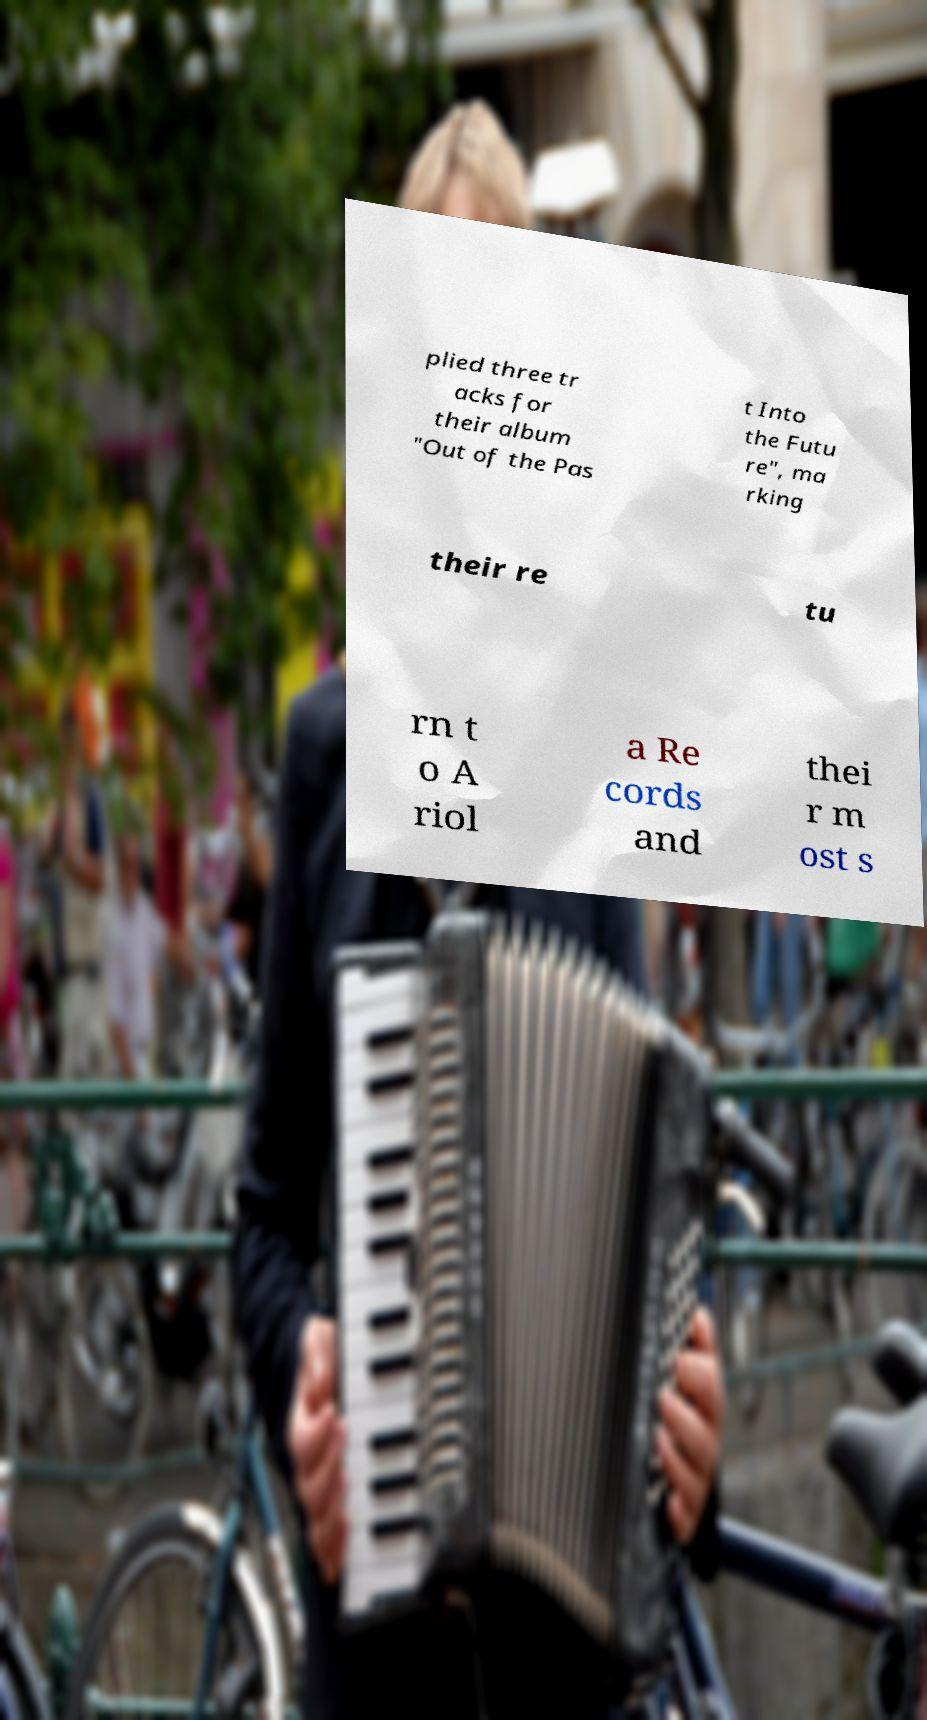Please read and relay the text visible in this image. What does it say? plied three tr acks for their album "Out of the Pas t Into the Futu re", ma rking their re tu rn t o A riol a Re cords and thei r m ost s 